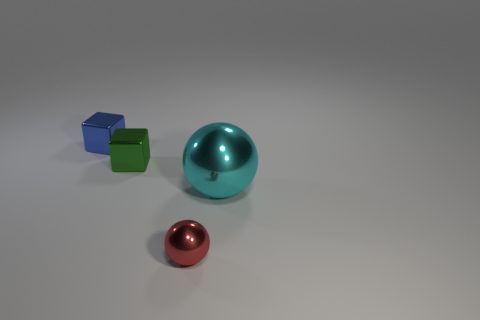What shape is the object that is both on the left side of the large metallic sphere and on the right side of the small green cube?
Offer a terse response. Sphere. There is a large shiny sphere; how many tiny shiny objects are in front of it?
Ensure brevity in your answer.  1. What size is the metallic thing that is both to the left of the large cyan ball and in front of the small green metallic object?
Offer a very short reply. Small. Are any small red shiny things visible?
Ensure brevity in your answer.  Yes. How many other things are the same size as the blue metal object?
Offer a very short reply. 2. Do the cube that is in front of the tiny blue metallic thing and the tiny object in front of the large cyan metal ball have the same color?
Offer a terse response. No. What is the size of the blue object that is the same shape as the small green object?
Offer a terse response. Small. Is the material of the tiny thing behind the green metallic cube the same as the cube in front of the small blue shiny object?
Give a very brief answer. Yes. What number of rubber objects are either large blue cubes or green cubes?
Your answer should be very brief. 0. What material is the ball that is on the right side of the tiny shiny object that is in front of the shiny object to the right of the red object?
Your answer should be very brief. Metal. 